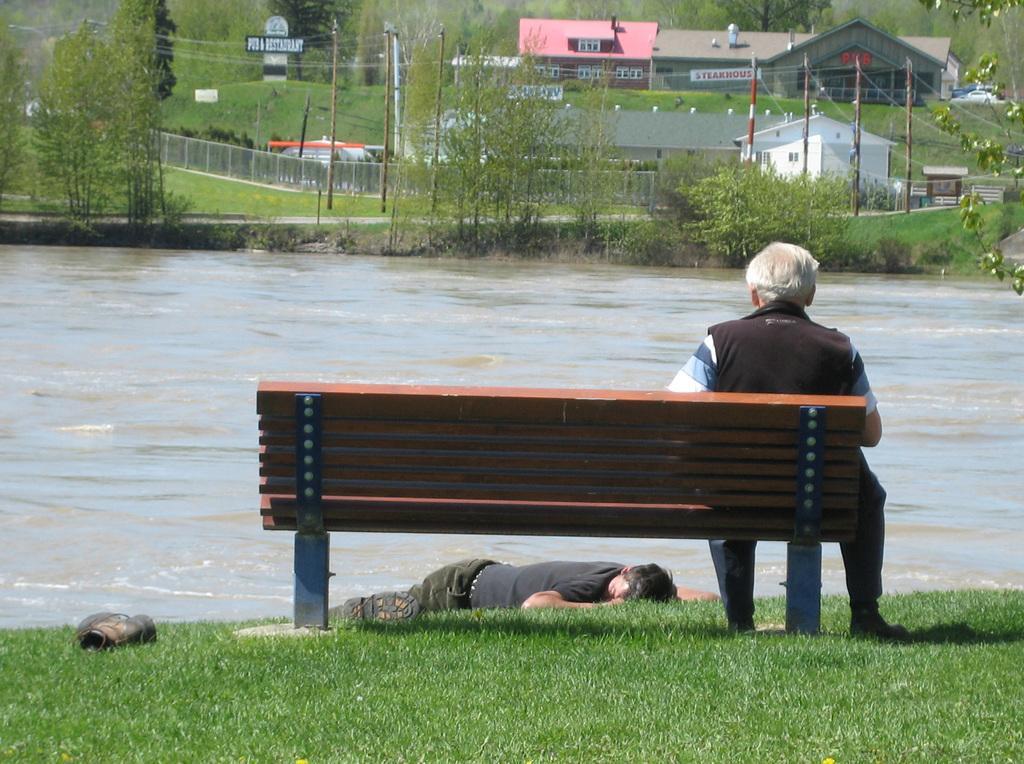Please provide a concise description of this image. In this image we can see a person sitting on the bench and the other person lying on the ground. In the background we can see buildings, electric poles, electric cables, fencing, shed, trees, plants and a lake. 